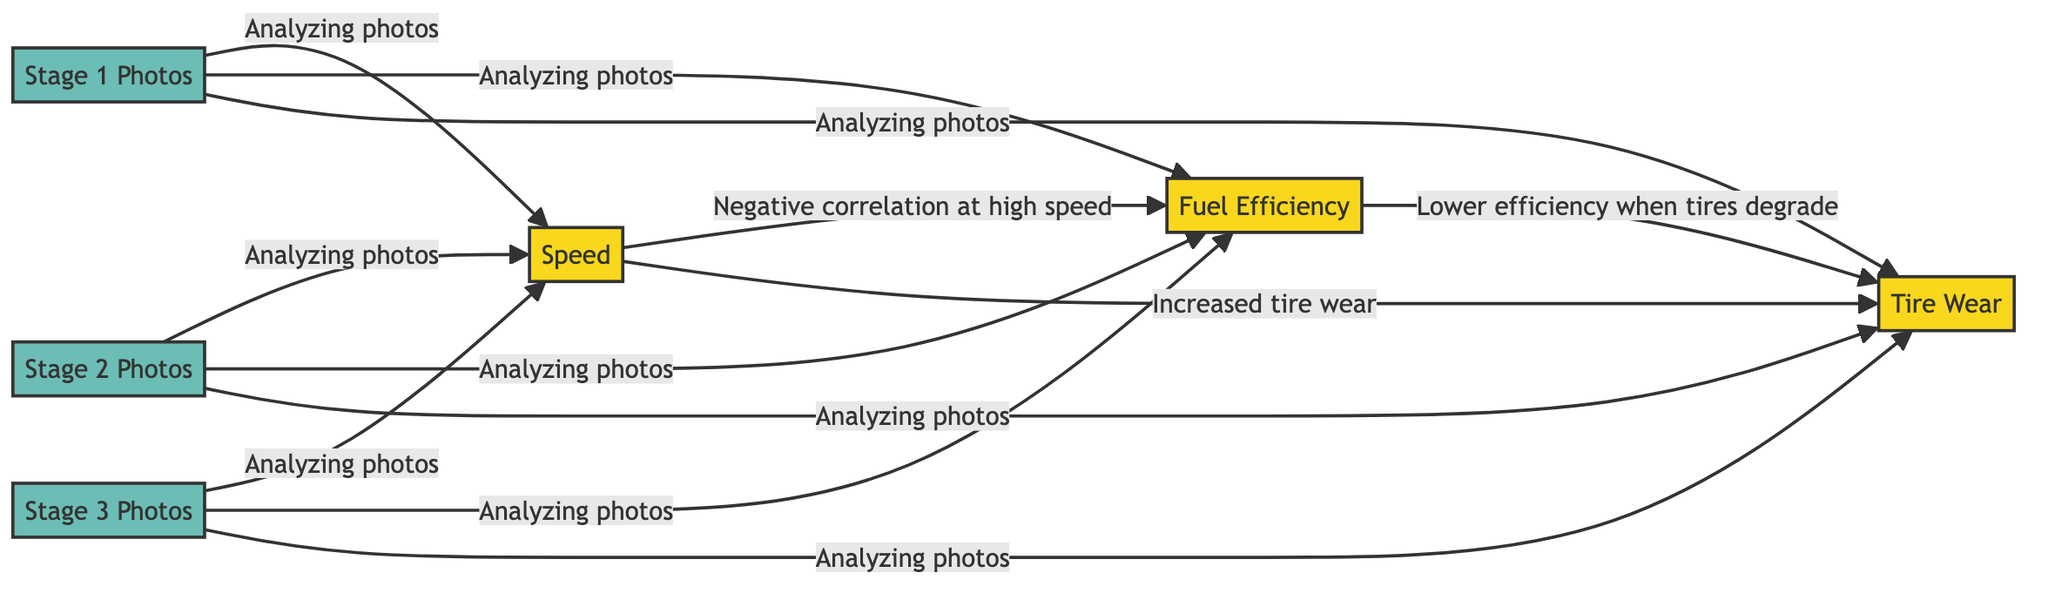What are the three performance metrics represented in the diagram? The diagram identifies three performance metrics: Speed, Fuel Efficiency, and Tire Wear. These are listed clearly as nodes in the diagram, all labeled "metric."
Answer: Speed, Fuel Efficiency, Tire Wear How many evidence nodes are included in this diagram? The diagram includes three evidence nodes: Stage 1 Photos, Stage 2 Photos, and Stage 3 Photos. These nodes are categorized as "evidence" nodes clearly shown in the diagram.
Answer: 3 What is the relationship between Speed and Fuel Efficiency? The diagram indicates a negative correlation between Speed and Fuel Efficiency by labeling the edge connecting these two nodes specifically "Negative correlation at high speed."
Answer: Negative correlation at high speed Which performance metric is connected to Tire Wear? Tire Wear is connected to Speed with the label "Increased tire wear," and it's also connected to Fuel Efficiency with the label "Lower efficiency when tires degrade." Thus, the relevant performance metrics are Speed and Fuel Efficiency.
Answer: Speed, Fuel Efficiency In which stage are photos analyzed with respect to all performance metrics? All performance metrics are supported by photographic evidence analyzed from the three stages (Stage 1, Stage 2, Stage 3). Each stage has edges labeled "Analyzing photos" toward each performance metric.
Answer: Stage 1, Stage 2, Stage 3 What type of correlation exists between Fuel Efficiency and Tire Wear? The relationship between Fuel Efficiency and Tire Wear is described as lower efficiency when tires degrade, indicating a negative relationship as tired condition worsens fuel efficiency.
Answer: Lower efficiency when tires degrade How many total edges are in this diagram? The diagram has a total of 12 edges connecting the performance metrics to each other and to the photographic evidence nodes, as listed throughout the edge connections.
Answer: 12 What does analyzing photos contribute to within this network? Analyzing photos contributes evidence supporting all three performance metrics (Speed, Fuel Efficiency, Tire Wear) from each of the three stages, showcasing a direct connection from photographic evidence to the metrics.
Answer: Evidence support for metrics 